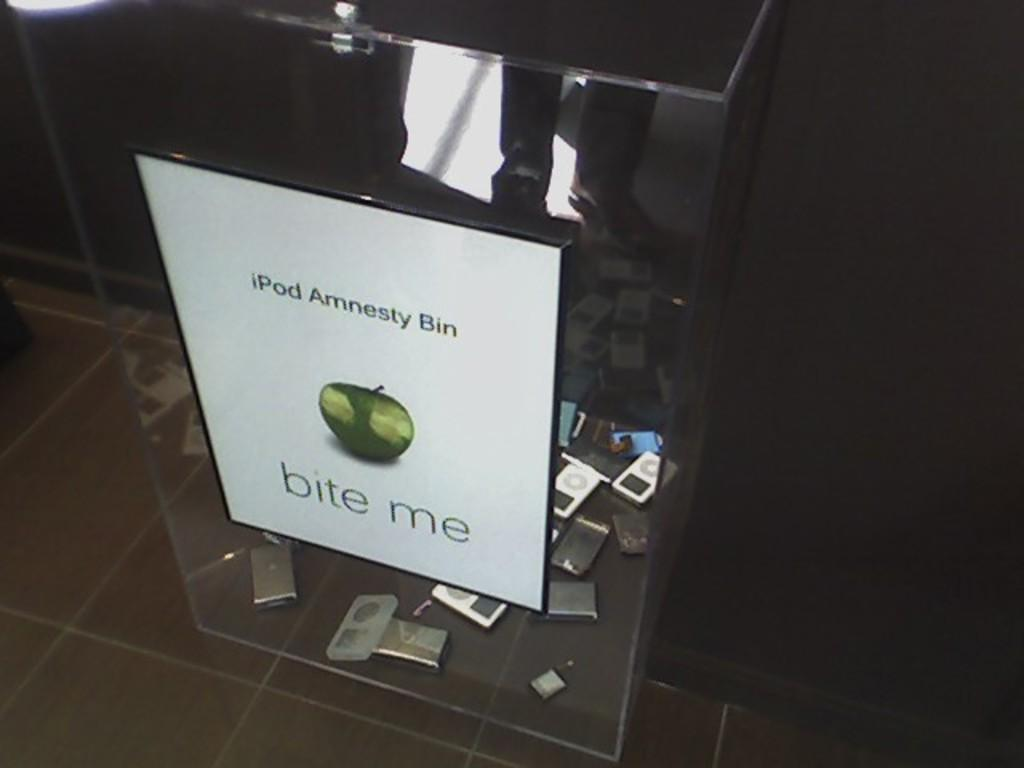What is the main object in the picture? There is a glass box in the picture. Where is the glass box located? The glass box is on the floor. What can be found inside the glass box? There are gadgets inside the glass box. Can you see a person reading a book in the library inside the glass box? There is no person, library, or book visible in the image; it only features a glass box with gadgets inside. 